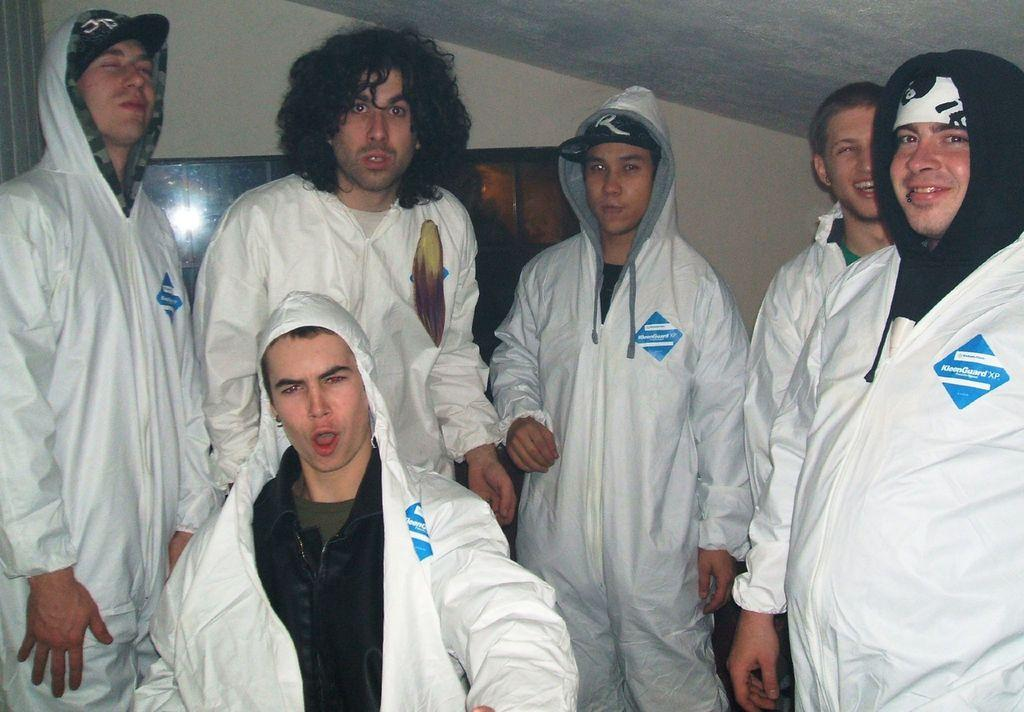<image>
Share a concise interpretation of the image provided. 6 men are wearing white uniforms with a logo Kleenguard in blue over the left chest, 